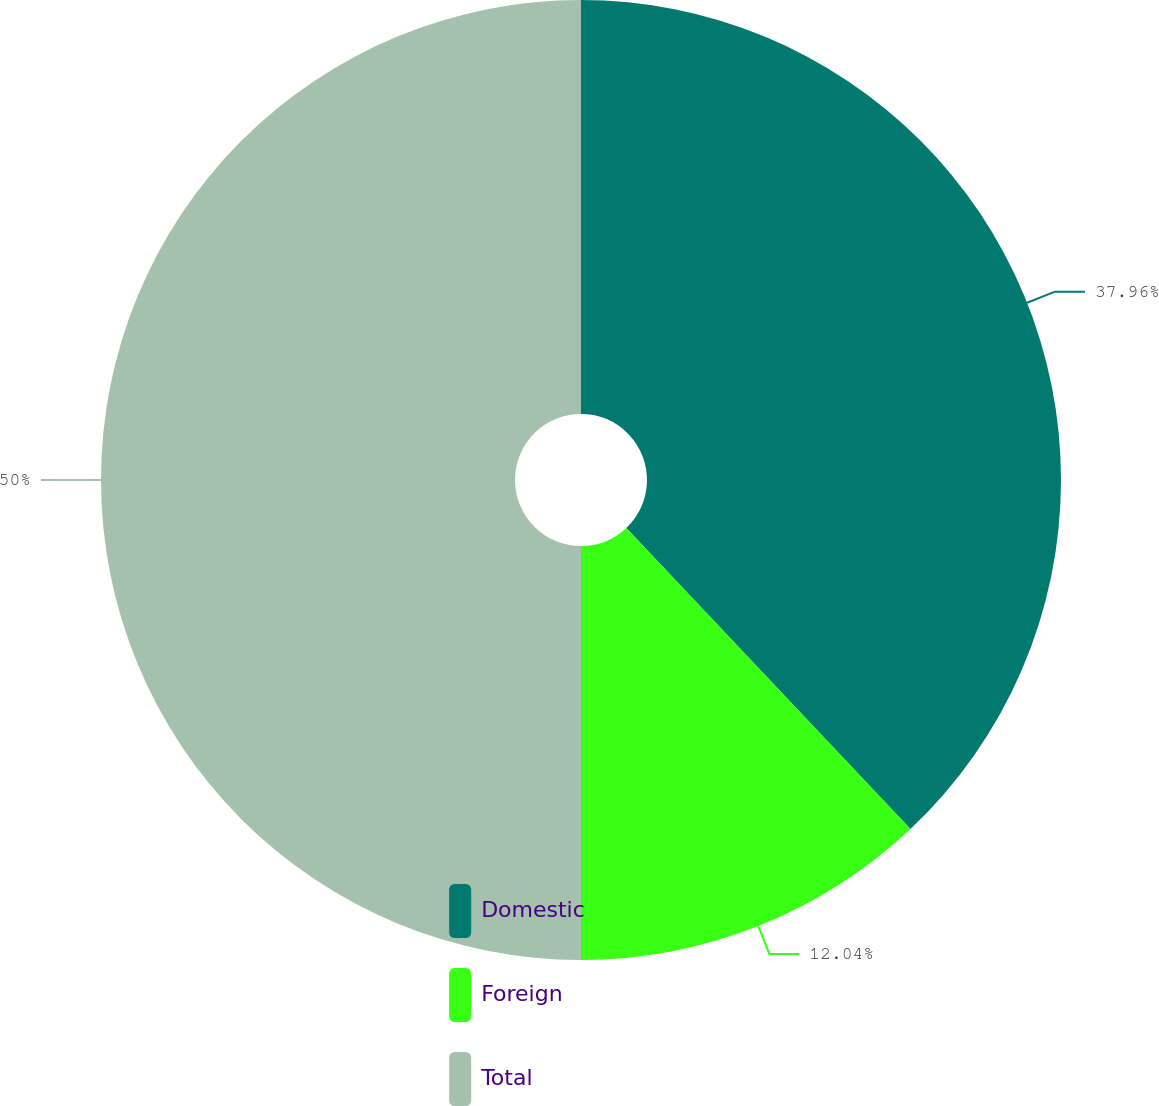Convert chart. <chart><loc_0><loc_0><loc_500><loc_500><pie_chart><fcel>Domestic<fcel>Foreign<fcel>Total<nl><fcel>37.96%<fcel>12.04%<fcel>50.0%<nl></chart> 